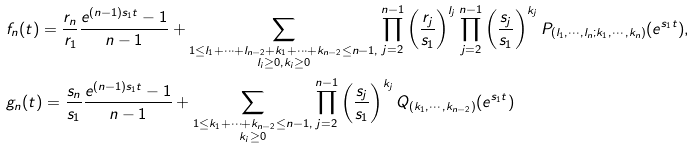Convert formula to latex. <formula><loc_0><loc_0><loc_500><loc_500>& f _ { n } ( t ) = \frac { r _ { n } } { r _ { 1 } } \frac { e ^ { ( n - 1 ) s _ { 1 } t } - 1 } { n - 1 } + \sum _ { \substack { 1 \leq l _ { 1 } + \cdots + l _ { n - 2 } + k _ { 1 } + \cdots + k _ { n - 2 } \leq n - 1 , \\ l _ { i } \geq 0 , k _ { i } \geq 0 } } \prod _ { j = 2 } ^ { n - 1 } \left ( \frac { r _ { j } } { s _ { 1 } } \right ) ^ { l _ { j } } \prod _ { j = 2 } ^ { n - 1 } \left ( \frac { s _ { j } } { s _ { 1 } } \right ) ^ { k _ { j } } P _ { ( l _ { 1 } , \cdots , l _ { n } ; k _ { 1 } , \cdots , k _ { n } ) } ( e ^ { s _ { 1 } t } ) , \\ & g _ { n } ( t ) = \frac { s _ { n } } { s _ { 1 } } \frac { e ^ { ( n - 1 ) s _ { 1 } t } - 1 } { n - 1 } + \sum _ { \substack { 1 \leq k _ { 1 } + \cdots + k _ { n - 2 } \leq n - 1 , \\ k _ { i } \geq 0 } } \prod _ { j = 2 } ^ { n - 1 } \left ( \frac { s _ { j } } { s _ { 1 } } \right ) ^ { k _ { j } } Q _ { ( k _ { 1 } , \cdots , k _ { n - 2 } ) } ( e ^ { s _ { 1 } t } )</formula> 